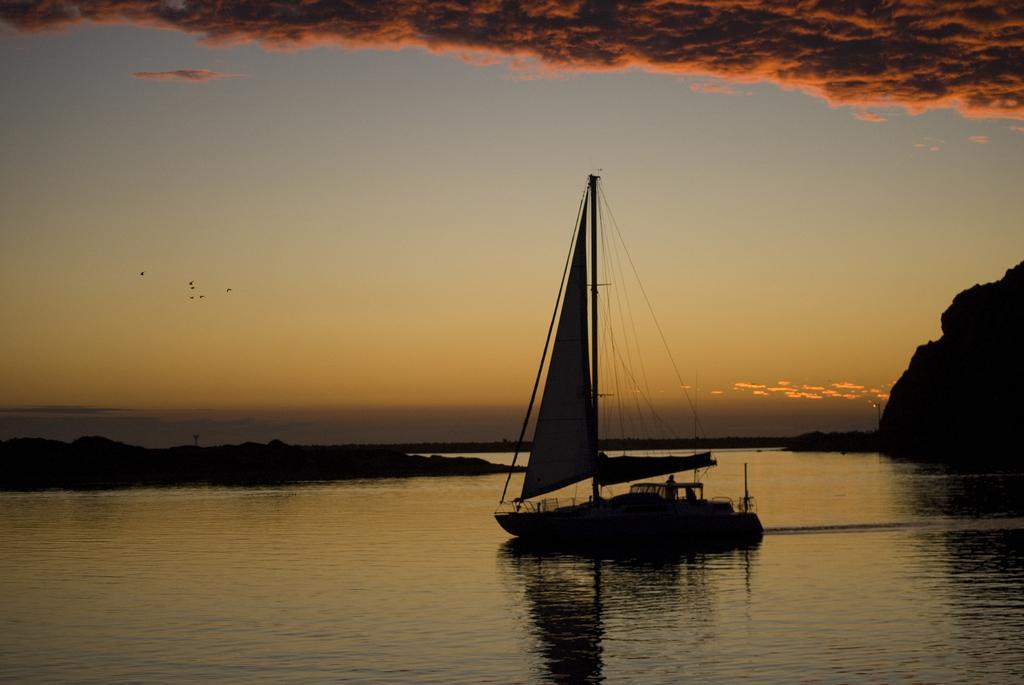Could you give a brief overview of what you see in this image? In this image there is the water. There is a boat on the water. In the background there are mountains and poles. At the top there is the sky. To the left there are birds flying in the sky. 